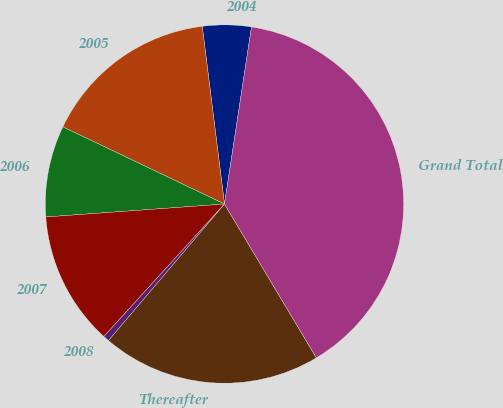Convert chart to OTSL. <chart><loc_0><loc_0><loc_500><loc_500><pie_chart><fcel>2004<fcel>2005<fcel>2006<fcel>2007<fcel>2008<fcel>Thereafter<fcel>Grand Total<nl><fcel>4.39%<fcel>15.93%<fcel>8.24%<fcel>12.09%<fcel>0.55%<fcel>19.78%<fcel>39.02%<nl></chart> 